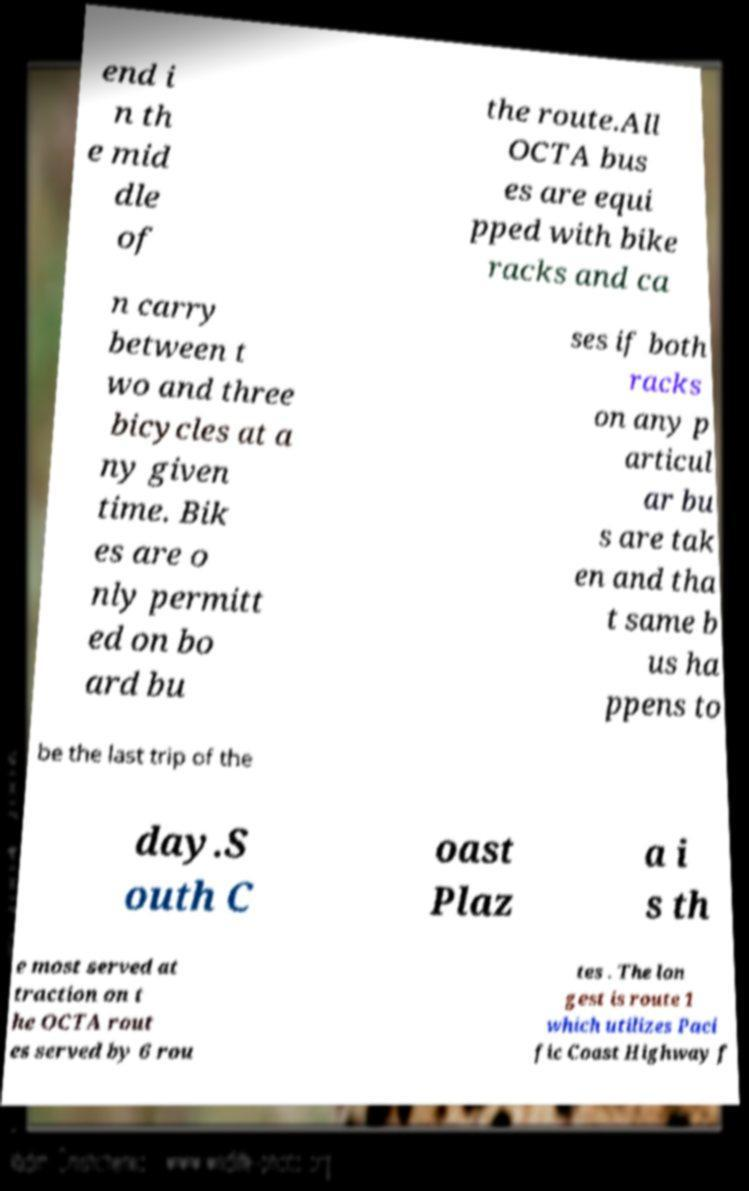There's text embedded in this image that I need extracted. Can you transcribe it verbatim? end i n th e mid dle of the route.All OCTA bus es are equi pped with bike racks and ca n carry between t wo and three bicycles at a ny given time. Bik es are o nly permitt ed on bo ard bu ses if both racks on any p articul ar bu s are tak en and tha t same b us ha ppens to be the last trip of the day.S outh C oast Plaz a i s th e most served at traction on t he OCTA rout es served by 6 rou tes . The lon gest is route 1 which utilizes Paci fic Coast Highway f 